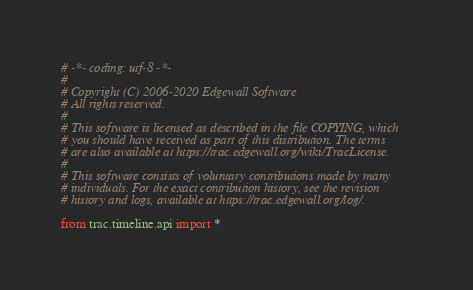<code> <loc_0><loc_0><loc_500><loc_500><_Python_># -*- coding: utf-8 -*-
#
# Copyright (C) 2006-2020 Edgewall Software
# All rights reserved.
#
# This software is licensed as described in the file COPYING, which
# you should have received as part of this distribution. The terms
# are also available at https://trac.edgewall.org/wiki/TracLicense.
#
# This software consists of voluntary contributions made by many
# individuals. For the exact contribution history, see the revision
# history and logs, available at https://trac.edgewall.org/log/.

from trac.timeline.api import *
</code> 